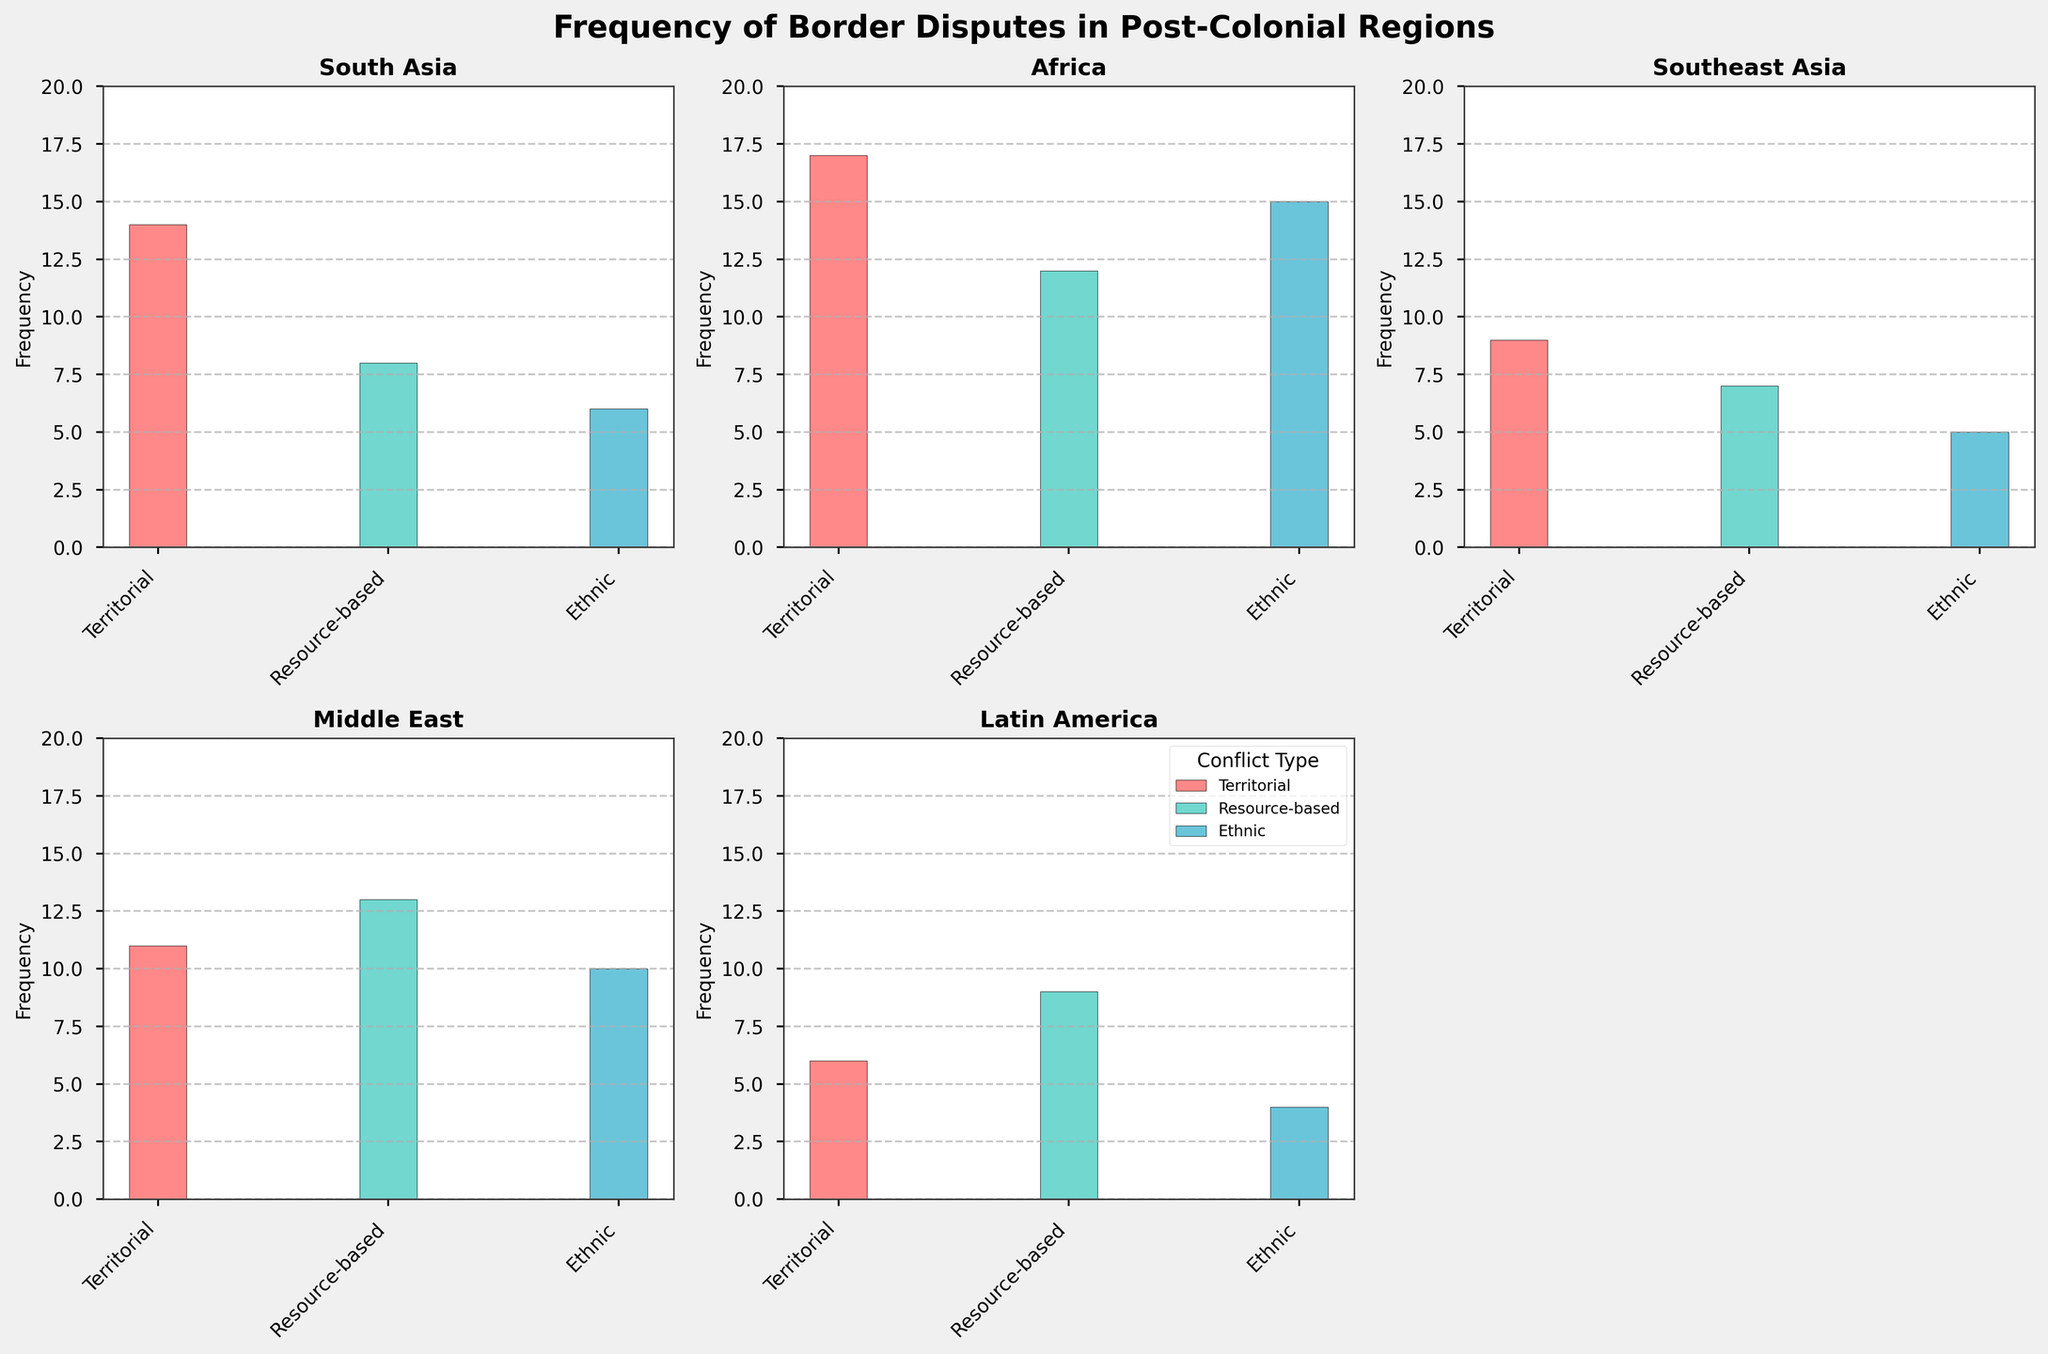What's the title of the figure? The title is located at the top center of the figure. It reads "Frequency of Border Disputes in Post-Colonial Regions."
Answer: Frequency of Border Disputes in Post-Colonial Regions What is the region with the highest frequency of territorial disputes? In the subplot for each region, the height of the bars representing territorial disputes can be compared. Africa has the tallest bar for territorial disputes with a frequency of 17.
Answer: Africa Which region has the least frequency of ethnic conflicts? In each subplot, compare the heights of the bars labeled as "Ethnic." Latin America has the smallest bar for ethnic conflicts with a frequency of 4.
Answer: Latin America How does the frequency of territorial disputes in South Asia compare to those in Southeast Asia? Compare the heights of the bars representing territorial disputes in the South Asia and Southeast Asia subplots. In South Asia, the frequency is 14, while in Southeast Asia, it is 9.
Answer: South Asia has a higher frequency What is the total frequency of conflicts in the Middle East? Sum the frequencies of all three types of conflicts in the Middle East subplot: Territorial (11), Resource-based (13), and Ethnic (10). The total is 11 + 13 + 10 = 34.
Answer: 34 Which conflict type has the highest frequency in the Middle East? In the Middle East subplot, the highest bar corresponds to the Resource-based conflicts with a frequency of 13.
Answer: Resource-based Compare the frequency of resource-based conflicts between Africa and Latin America. In the subplots for Africa and Latin America, compare the bars representing resource-based conflicts. Africa has a frequency of 12 and Latin America has a frequency of 9.
Answer: Africa has a higher frequency How do the frequencies of ethnic conflicts in Southeast Asia and Africa differ? Compare the heights of the bars for ethnic conflicts in the Southeast Asia subplot (5) and the Africa subplot (15). The difference is 15 - 5 = 10.
Answer: Africa has 10 more ethnic conflicts What is the average frequency of territorial conflicts across all regions? Add the frequencies of territorial conflicts for all regions: South Asia (14), Africa (17), Southeast Asia (9), Middle East (11), Latin America (6). Divide the total by the number of regions (5). The sum is 14 + 17 + 9 + 11 + 6 = 57. The average is 57 / 5 = 11.4.
Answer: 11.4 Which region has the most balanced distribution of conflict types? Observe the heights of the bars for each region to see which has the least variation among the three types of conflicts. The Middle East has fairly evenly distributed frequencies of 11, 13, and 10.
Answer: Middle East 